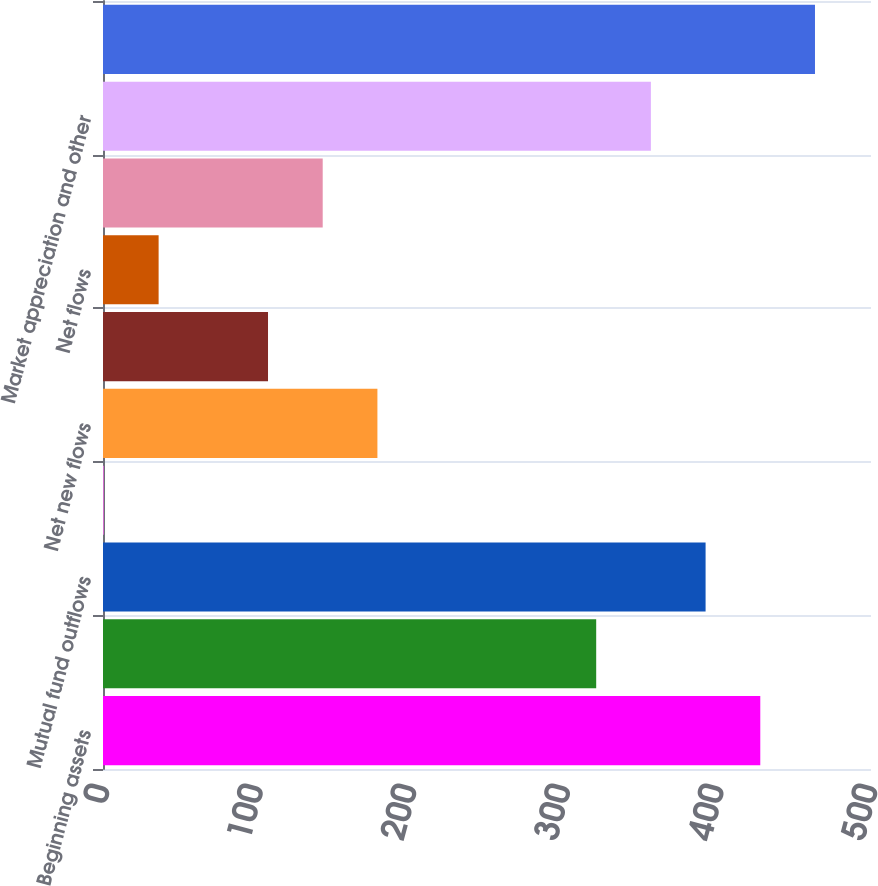<chart> <loc_0><loc_0><loc_500><loc_500><bar_chart><fcel>Beginning assets<fcel>Mutual fund inflows<fcel>Mutual fund outflows<fcel>Net VP/VIT fund flows<fcel>Net new flows<fcel>Reinvested dividends<fcel>Net flows<fcel>Distributions<fcel>Market appreciation and other<fcel>Total ending assets<nl><fcel>427.92<fcel>321.09<fcel>392.31<fcel>0.6<fcel>178.65<fcel>107.43<fcel>36.21<fcel>143.04<fcel>356.7<fcel>463.53<nl></chart> 